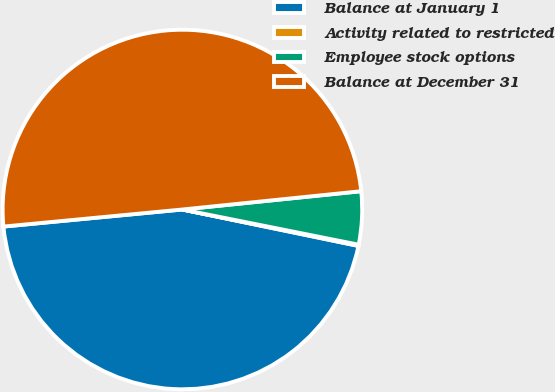Convert chart. <chart><loc_0><loc_0><loc_500><loc_500><pie_chart><fcel>Balance at January 1<fcel>Activity related to restricted<fcel>Employee stock options<fcel>Balance at December 31<nl><fcel>45.24%<fcel>0.11%<fcel>4.76%<fcel>49.89%<nl></chart> 